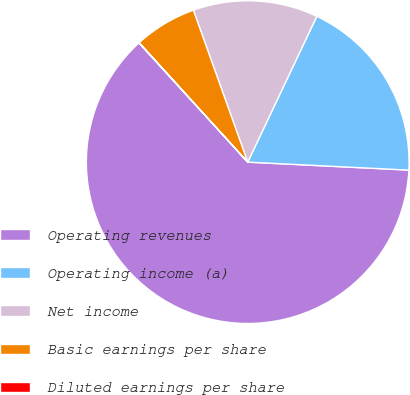Convert chart to OTSL. <chart><loc_0><loc_0><loc_500><loc_500><pie_chart><fcel>Operating revenues<fcel>Operating income (a)<fcel>Net income<fcel>Basic earnings per share<fcel>Diluted earnings per share<nl><fcel>62.45%<fcel>18.75%<fcel>12.51%<fcel>6.27%<fcel>0.03%<nl></chart> 